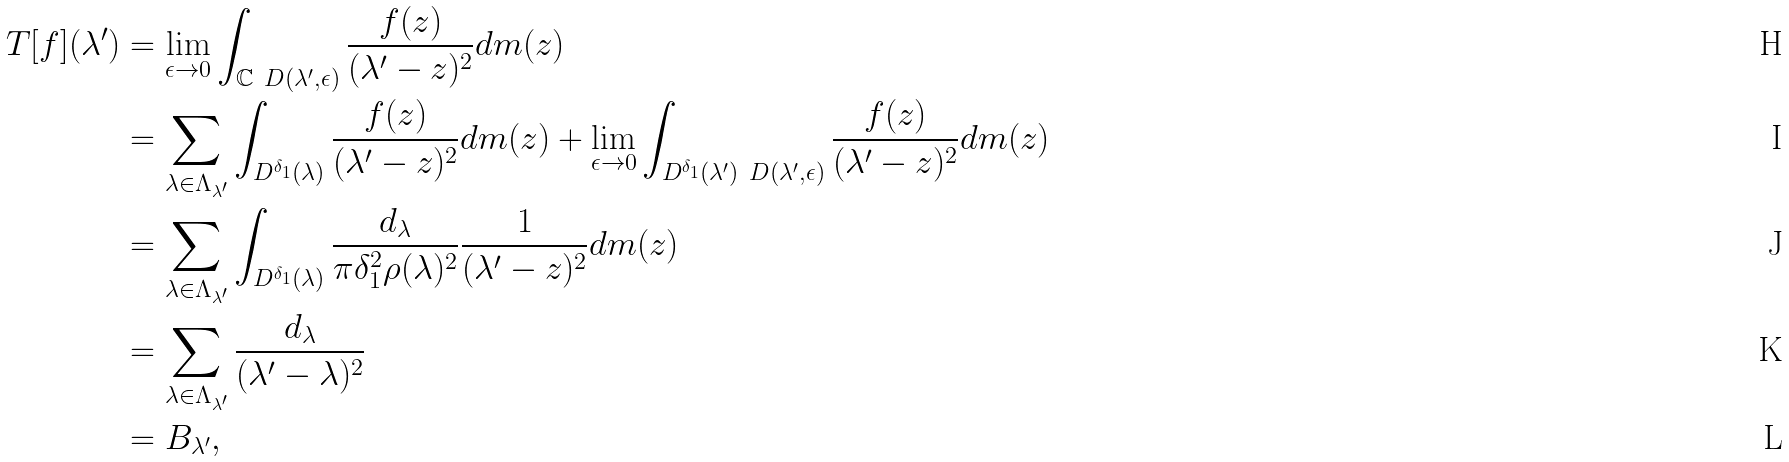<formula> <loc_0><loc_0><loc_500><loc_500>T [ f ] ( \lambda ^ { \prime } ) & = \lim _ { \epsilon \rightarrow 0 } \int _ { \mathbb { C } \ D ( \lambda ^ { \prime } , \epsilon ) } \frac { f ( z ) } { ( \lambda ^ { \prime } - z ) ^ { 2 } } d m ( z ) \\ & = \sum _ { \lambda \in \Lambda _ { \lambda ^ { \prime } } } \int _ { D ^ { \delta _ { 1 } } ( \lambda ) } \frac { f ( z ) } { ( \lambda ^ { \prime } - z ) ^ { 2 } } d m ( z ) + \lim _ { \epsilon \rightarrow 0 } \int _ { D ^ { \delta _ { 1 } } ( \lambda ^ { \prime } ) \ D ( \lambda ^ { \prime } , \epsilon ) } \frac { f ( z ) } { ( \lambda ^ { \prime } - z ) ^ { 2 } } d m ( z ) \\ & = \sum _ { \lambda \in \Lambda _ { \lambda ^ { \prime } } } \int _ { D ^ { \delta _ { 1 } } ( \lambda ) } \frac { d _ { \lambda } } { \pi \delta _ { 1 } ^ { 2 } \rho ( \lambda ) ^ { 2 } } \frac { 1 } { ( \lambda ^ { \prime } - z ) ^ { 2 } } d m ( z ) \\ & = \sum _ { \lambda \in \Lambda _ { \lambda ^ { \prime } } } \frac { d _ { \lambda } } { ( \lambda ^ { \prime } - \lambda ) ^ { 2 } } \\ & = B _ { \lambda ^ { \prime } } ,</formula> 